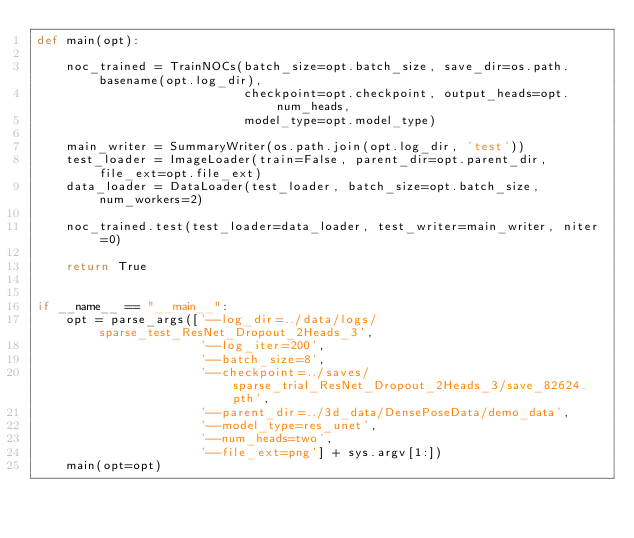Convert code to text. <code><loc_0><loc_0><loc_500><loc_500><_Python_>def main(opt):

    noc_trained = TrainNOCs(batch_size=opt.batch_size, save_dir=os.path.basename(opt.log_dir),
                            checkpoint=opt.checkpoint, output_heads=opt.num_heads,
                            model_type=opt.model_type)

    main_writer = SummaryWriter(os.path.join(opt.log_dir, 'test'))
    test_loader = ImageLoader(train=False, parent_dir=opt.parent_dir, file_ext=opt.file_ext)
    data_loader = DataLoader(test_loader, batch_size=opt.batch_size, num_workers=2)

    noc_trained.test(test_loader=data_loader, test_writer=main_writer, niter=0)

    return True


if __name__ == "__main__":
    opt = parse_args(['--log_dir=../data/logs/sparse_test_ResNet_Dropout_2Heads_3',
                      '--log_iter=200',
                      '--batch_size=8',
                      '--checkpoint=../saves/sparse_trial_ResNet_Dropout_2Heads_3/save_82624.pth',
                      '--parent_dir=../3d_data/DensePoseData/demo_data',
                      '--model_type=res_unet',
                      '--num_heads=two',
                      '--file_ext=png'] + sys.argv[1:])
    main(opt=opt)

</code> 